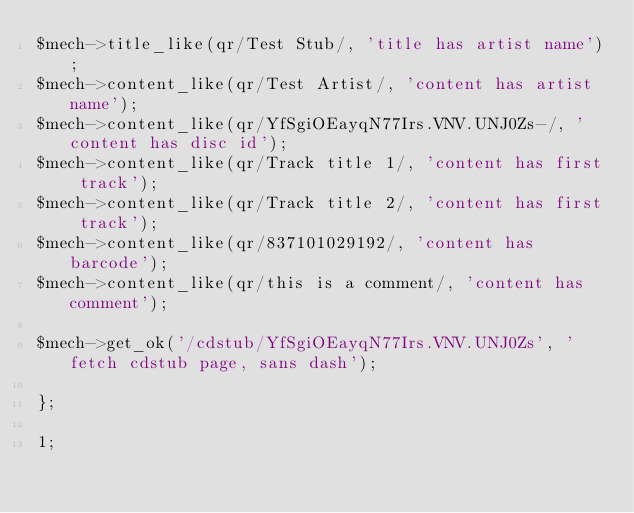<code> <loc_0><loc_0><loc_500><loc_500><_Perl_>$mech->title_like(qr/Test Stub/, 'title has artist name');
$mech->content_like(qr/Test Artist/, 'content has artist name');
$mech->content_like(qr/YfSgiOEayqN77Irs.VNV.UNJ0Zs-/, 'content has disc id');
$mech->content_like(qr/Track title 1/, 'content has first track');
$mech->content_like(qr/Track title 2/, 'content has first track');
$mech->content_like(qr/837101029192/, 'content has barcode');
$mech->content_like(qr/this is a comment/, 'content has comment');

$mech->get_ok('/cdstub/YfSgiOEayqN77Irs.VNV.UNJ0Zs', 'fetch cdstub page, sans dash');

};

1;
</code> 